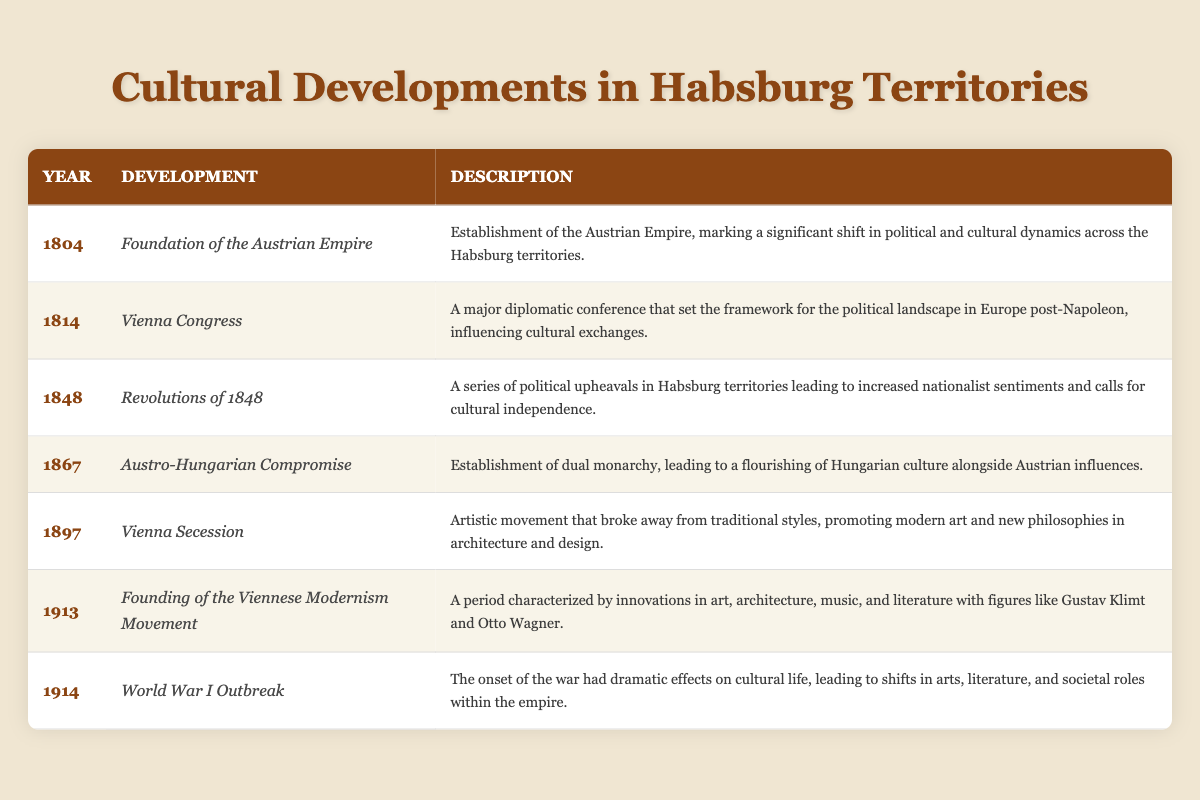What year did the Foundation of the Austrian Empire occur? Referring to the table, the year of the Foundation of the Austrian Empire is listed as 1804.
Answer: 1804 What major event took place in 1814 in the Habsburg territories? The table identifies the Vienna Congress as a major event in 1814.
Answer: Vienna Congress How many cultural developments are listed in the table? By counting the rows in the table, there are a total of 7 cultural developments listed.
Answer: 7 In what year did the Revolutions of 1848 occur? The table specifies that the Revolutions of 1848 took place in the year 1848.
Answer: 1848 Was the Vienna Secession an event that promoted traditional styles? The table mentions that the Vienna Secession broke away from traditional styles, indicating that it did not promote them.
Answer: No What significant cultural change happened in 1867? The Austro-Hungarian Compromise is noted in the table as a significant cultural change, establishing a dual monarchy that led to cultural flourishing.
Answer: Austro-Hungarian Compromise Which development immediately preceded the outbreak of World War I? The table states that the Founding of the Viennese Modernism Movement occurred in 1913, which directly precedes the outbreak of World War I in 1914.
Answer: Founding of the Viennese Modernism Movement How many years are between the Foundation of the Austrian Empire and the Vienna Congess? The Foundation of the Austrian Empire occurred in 1804 and the Vienna Congress in 1814, resulting in a 10-year difference between the two events.
Answer: 10 years What type of cultural movement emerged in 1897 according to the table? The table describes the Vienna Secession as an artistic movement promoting modern art and new philosophies, indicating its nature as a cultural movement.
Answer: An artistic movement 